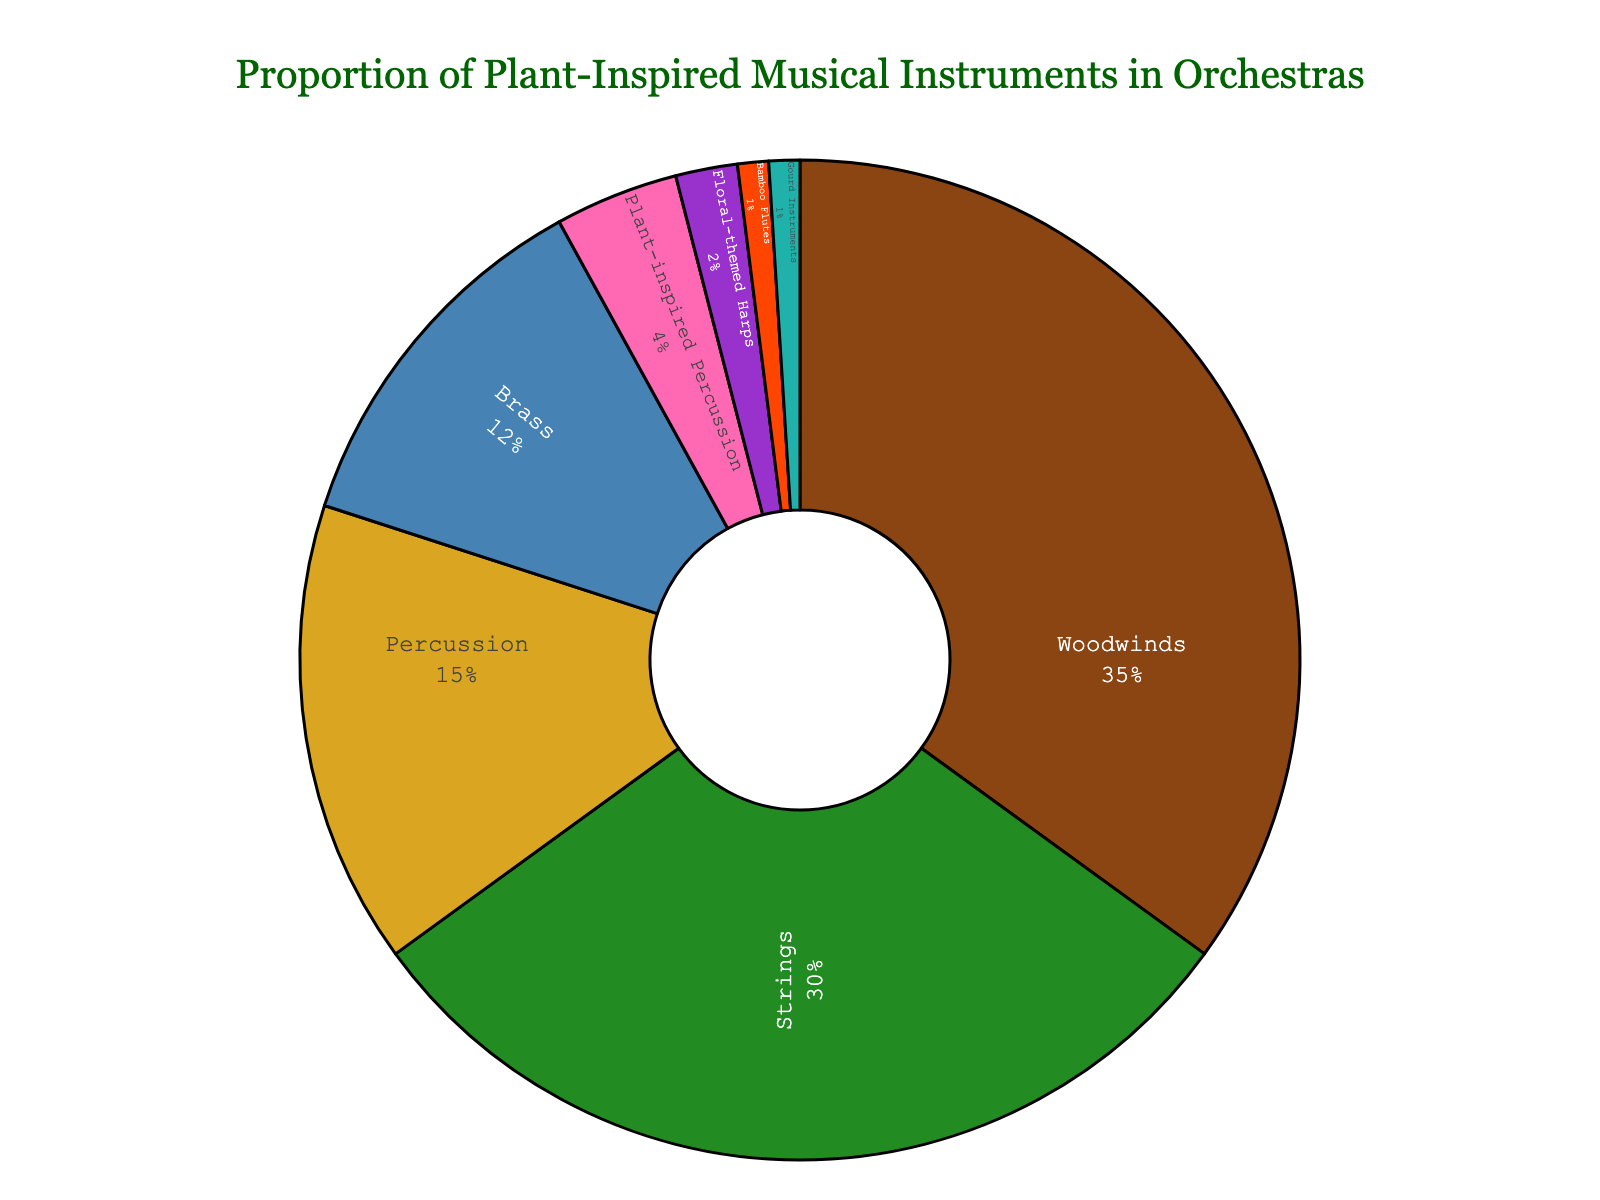What percentage does the combination of floral-themed Harps and Gourd Instruments make up? Add the percentages of floral-themed Harps (2%) and Gourd Instruments (1%) to find the combined percentage.
Answer: 3% Which category has the largest share in the pie chart? The Woodwinds category has the highest percentage at 35%, making it the largest share.
Answer: Woodwinds Is the proportion of Plant-inspired Percussion greater than or less than the proportion of Brass instruments? The proportion of Plant-inspired Percussion is 4%, whereas the proportion of Brass instruments is 12%. Since 4% is less than 12%, Plant-inspired Percussion is less.
Answer: Less How much larger is the percentage of Strings compared to the sum of Plant-inspired Percussion and Bamboo Flutes? The percentage of Strings is 30%. The sum of Plant-inspired Percussion (4%) and Bamboo Flutes (1%) is 5%. The difference is 30% - 5% = 25%.
Answer: 25% What is the total percentage of plant-inspired musical instruments? The plant-inspired categories are Plant-inspired Percussion (4%), Floral-themed Harps (2%), Bamboo Flutes (1%), and Gourd Instruments (1%). Summing them: 4% + 2% + 1% + 1% = 8%.
Answer: 8% Which category contributes the smallest percentage to the pie chart? Both Bamboo Flutes and Gourd Instruments contribute 1%, which is the smallest percentage in the chart.
Answer: Bamboo Flutes and Gourd Instruments Are the percentages of Woodwinds and Strings equal? Woodwinds are 35% and Strings are 30%, so they are not equal.
Answer: No What is the combined percentage of categories that are not plant-inspired? The non-plant-inspired categories are Woodwinds (35%), Strings (30%), Percussion (15%), and Brass (12%). Summing them: 35% + 30% + 15% + 12% = 92%.
Answer: 92% Which is greater: the combined percentage of wood-based instruments (Woodwinds and Bamboo Flutes) or the percentage of Strings? Combined percentage of wood-based instruments is Woodwinds (35%) + Bamboo Flutes (1%) = 36%. Strings are 30%. Since 36% > 30%, the wood-based instruments have a greater percentage.
Answer: Wood-based instruments 